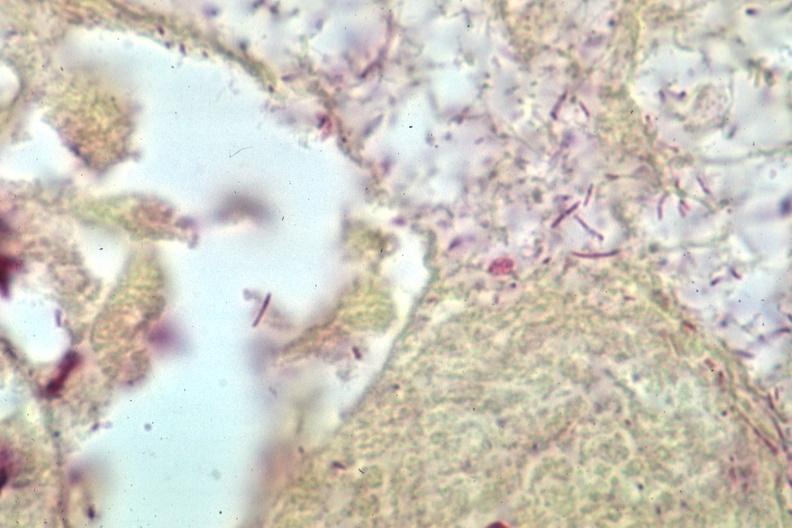what stain gram negative bacteria?
Answer the question using a single word or phrase. Grams 